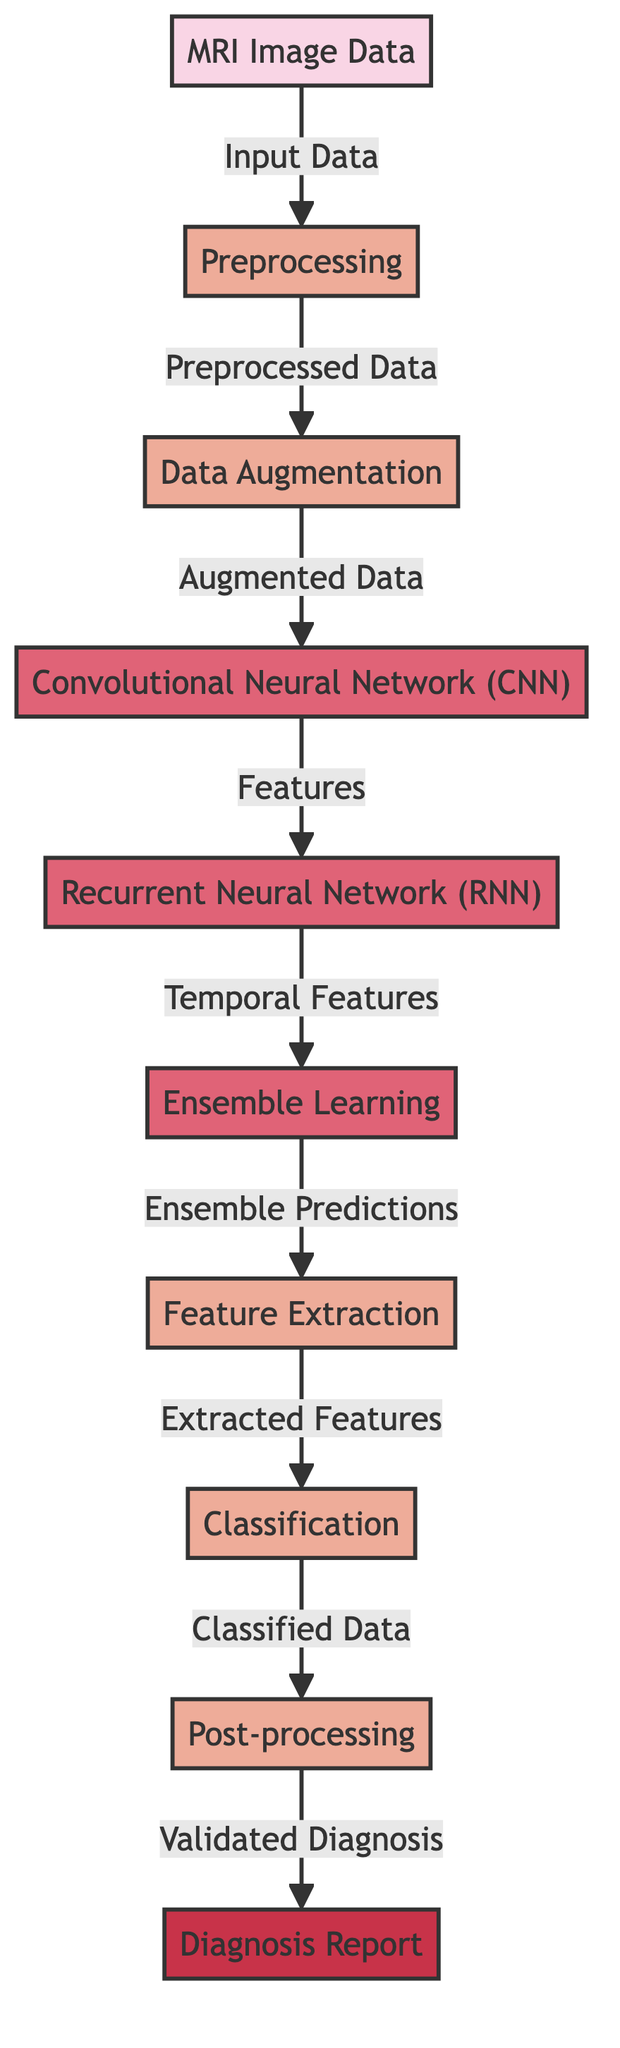What is the final output of the process? The diagram clearly shows that the flow ends with the node labeled "Diagnosis Report," which signifies the output of the entire processing sequence.
Answer: Diagnosis Report How many types of neural network architectures are present in the diagram? The diagram includes three types of neural network architectures: Convolutional Neural Network, Recurrent Neural Network, and Ensemble Learning. By counting these distinct nodes, we see that there are a total of three.
Answer: Three What step comes immediately after data augmentation? Following the node "Data Augmentation," the flowchart shows the next step as "Convolutional Neural Network (CNN)." This is indicated by a direct connection from the augmentation step to the CNN node.
Answer: Convolutional Neural Network What type of data is used as input? The diagram identifies "MRI Image Data" as the input to the entire process. This is explicitly labeled as the starting point in the flowchart.
Answer: MRI Image Data What processing step follows feature extraction? After the "Feature Extraction" step, the next process in the sequence is "Classification." This is shown in the diagram as a direct connection leading to the classification node.
Answer: Classification Which algorithm processes temporal features? The "Recurrent Neural Network (RNN)" is responsible for processing temporal features, as indicated by the flow leading from the CNN to the RNN node in the diagram.
Answer: Recurrent Neural Network What type of processing occurs before post-processing? Prior to reaching "Post-processing," the data goes through a "Classification" step. The diagram shows the flow leading sequentially from classification to post-processing.
Answer: Classification How do the two neural network architectures interact? The Convolutional Neural Network (CNN) provides features to the Recurrent Neural Network (RNN), and then the RNN sends temporal features to the Ensemble Learning algorithm, indicating a flow of information between these architectures.
Answer: Features and Temporal Features What is the role of data augmentation in the overall processing? Data augmentation serves as a critical step that follows preprocessing, aimed at enhancing the input data, which is demonstrated by its position before passing on to the CNN.
Answer: Enhancing Input Data 